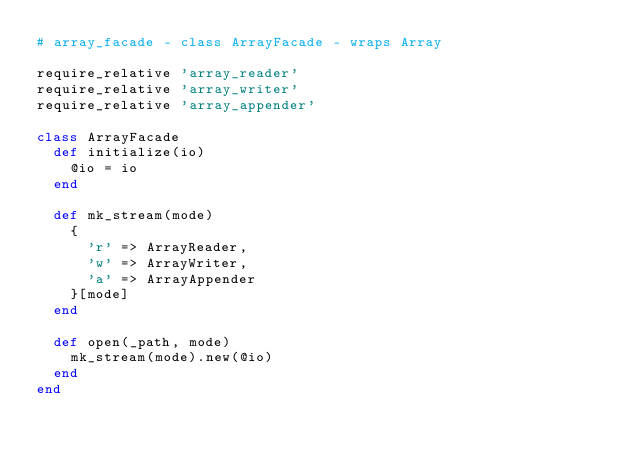<code> <loc_0><loc_0><loc_500><loc_500><_Ruby_># array_facade - class ArrayFacade - wraps Array

require_relative 'array_reader'
require_relative 'array_writer'
require_relative 'array_appender'

class ArrayFacade
  def initialize(io)
    @io = io
  end

  def mk_stream(mode)
    {
      'r' => ArrayReader,
      'w' => ArrayWriter,
      'a' => ArrayAppender
    }[mode]
  end

  def open(_path, mode)
    mk_stream(mode).new(@io)
  end
end
</code> 